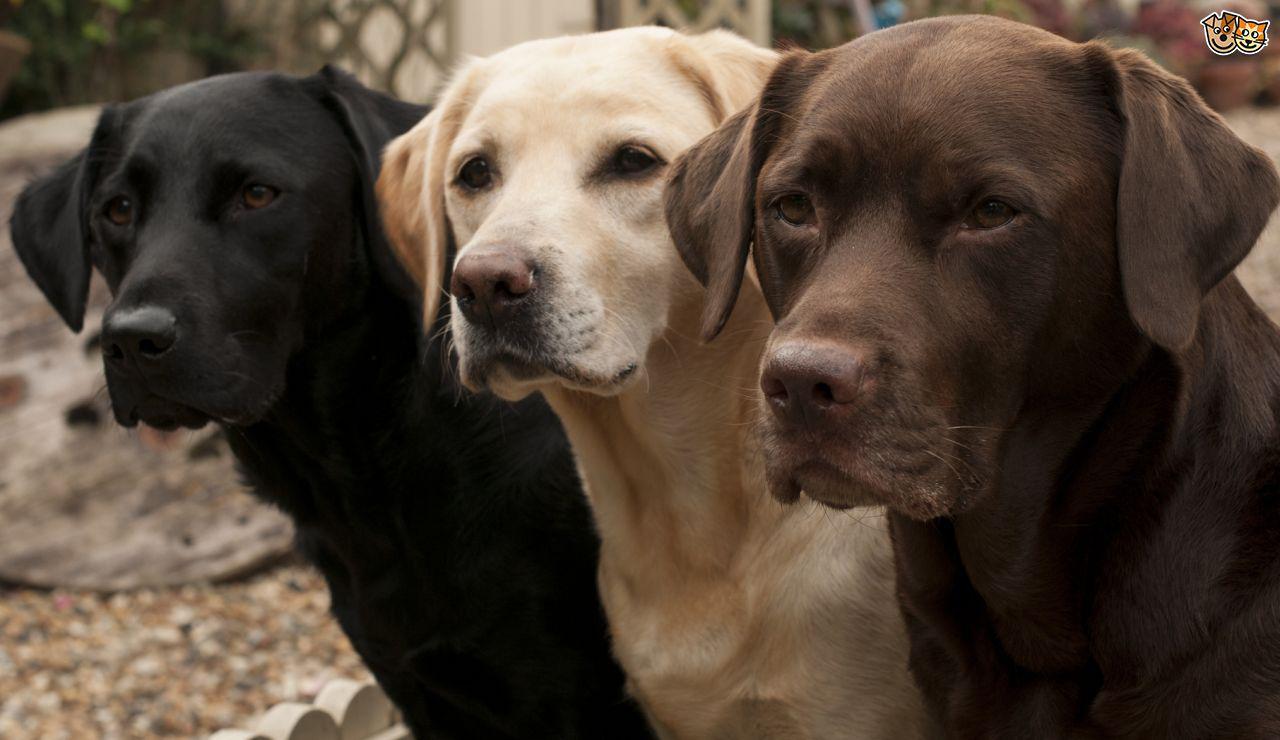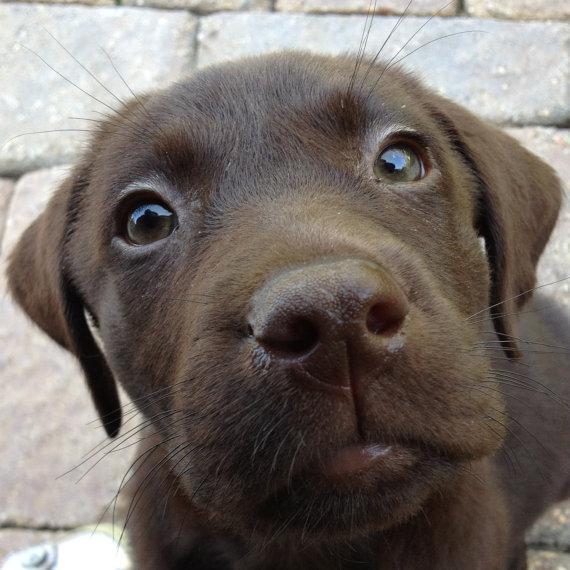The first image is the image on the left, the second image is the image on the right. Assess this claim about the two images: "There are at least four dogs.". Correct or not? Answer yes or no. Yes. 